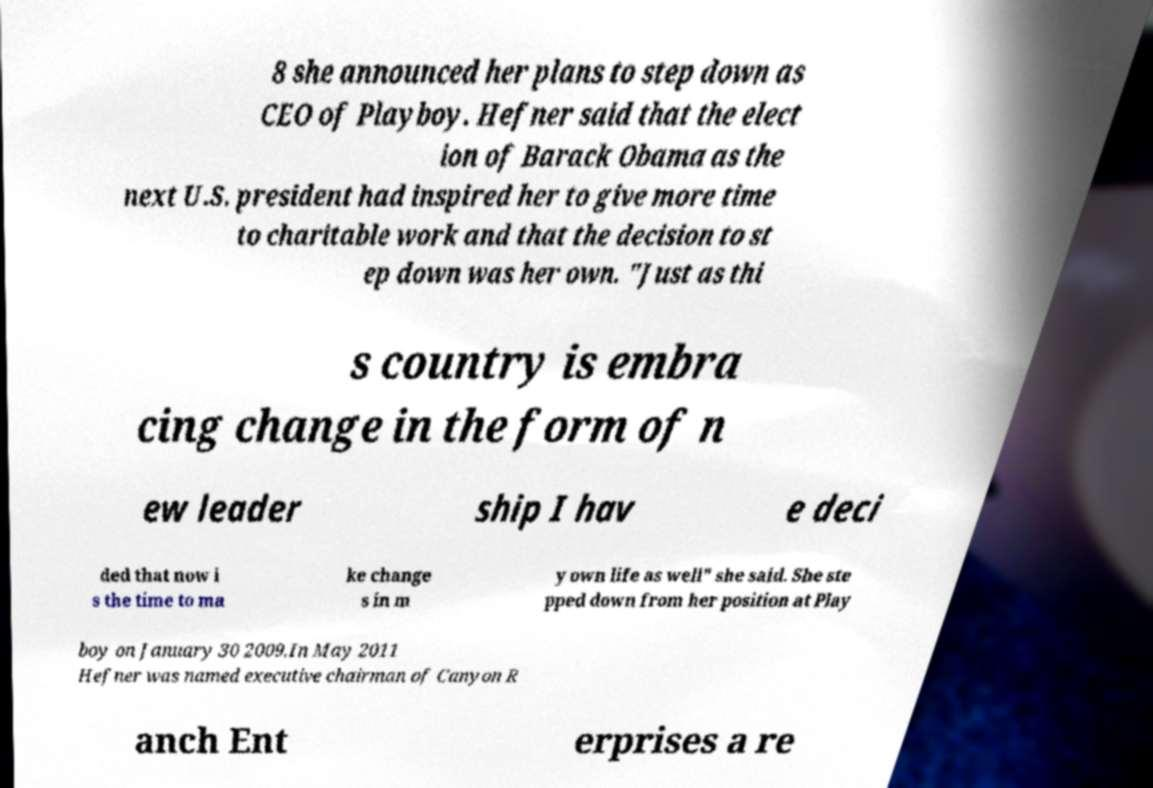Please read and relay the text visible in this image. What does it say? 8 she announced her plans to step down as CEO of Playboy. Hefner said that the elect ion of Barack Obama as the next U.S. president had inspired her to give more time to charitable work and that the decision to st ep down was her own. "Just as thi s country is embra cing change in the form of n ew leader ship I hav e deci ded that now i s the time to ma ke change s in m y own life as well" she said. She ste pped down from her position at Play boy on January 30 2009.In May 2011 Hefner was named executive chairman of Canyon R anch Ent erprises a re 